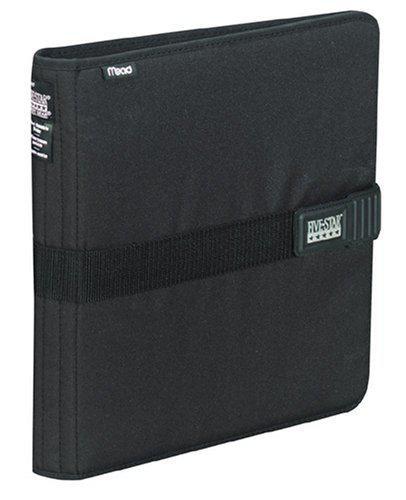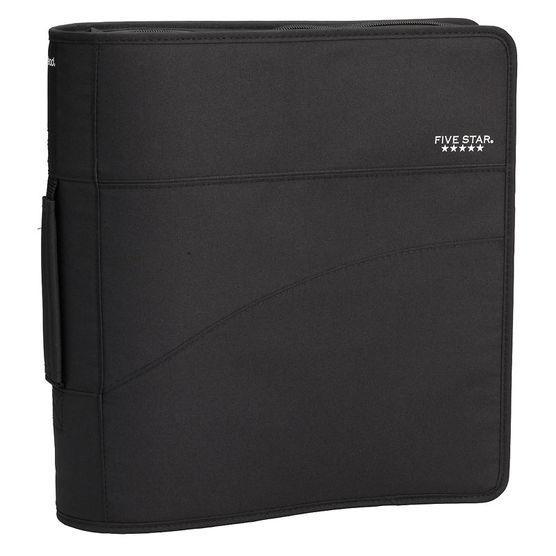The first image is the image on the left, the second image is the image on the right. Assess this claim about the two images: "The case in one of the images is blue.". Correct or not? Answer yes or no. No. 